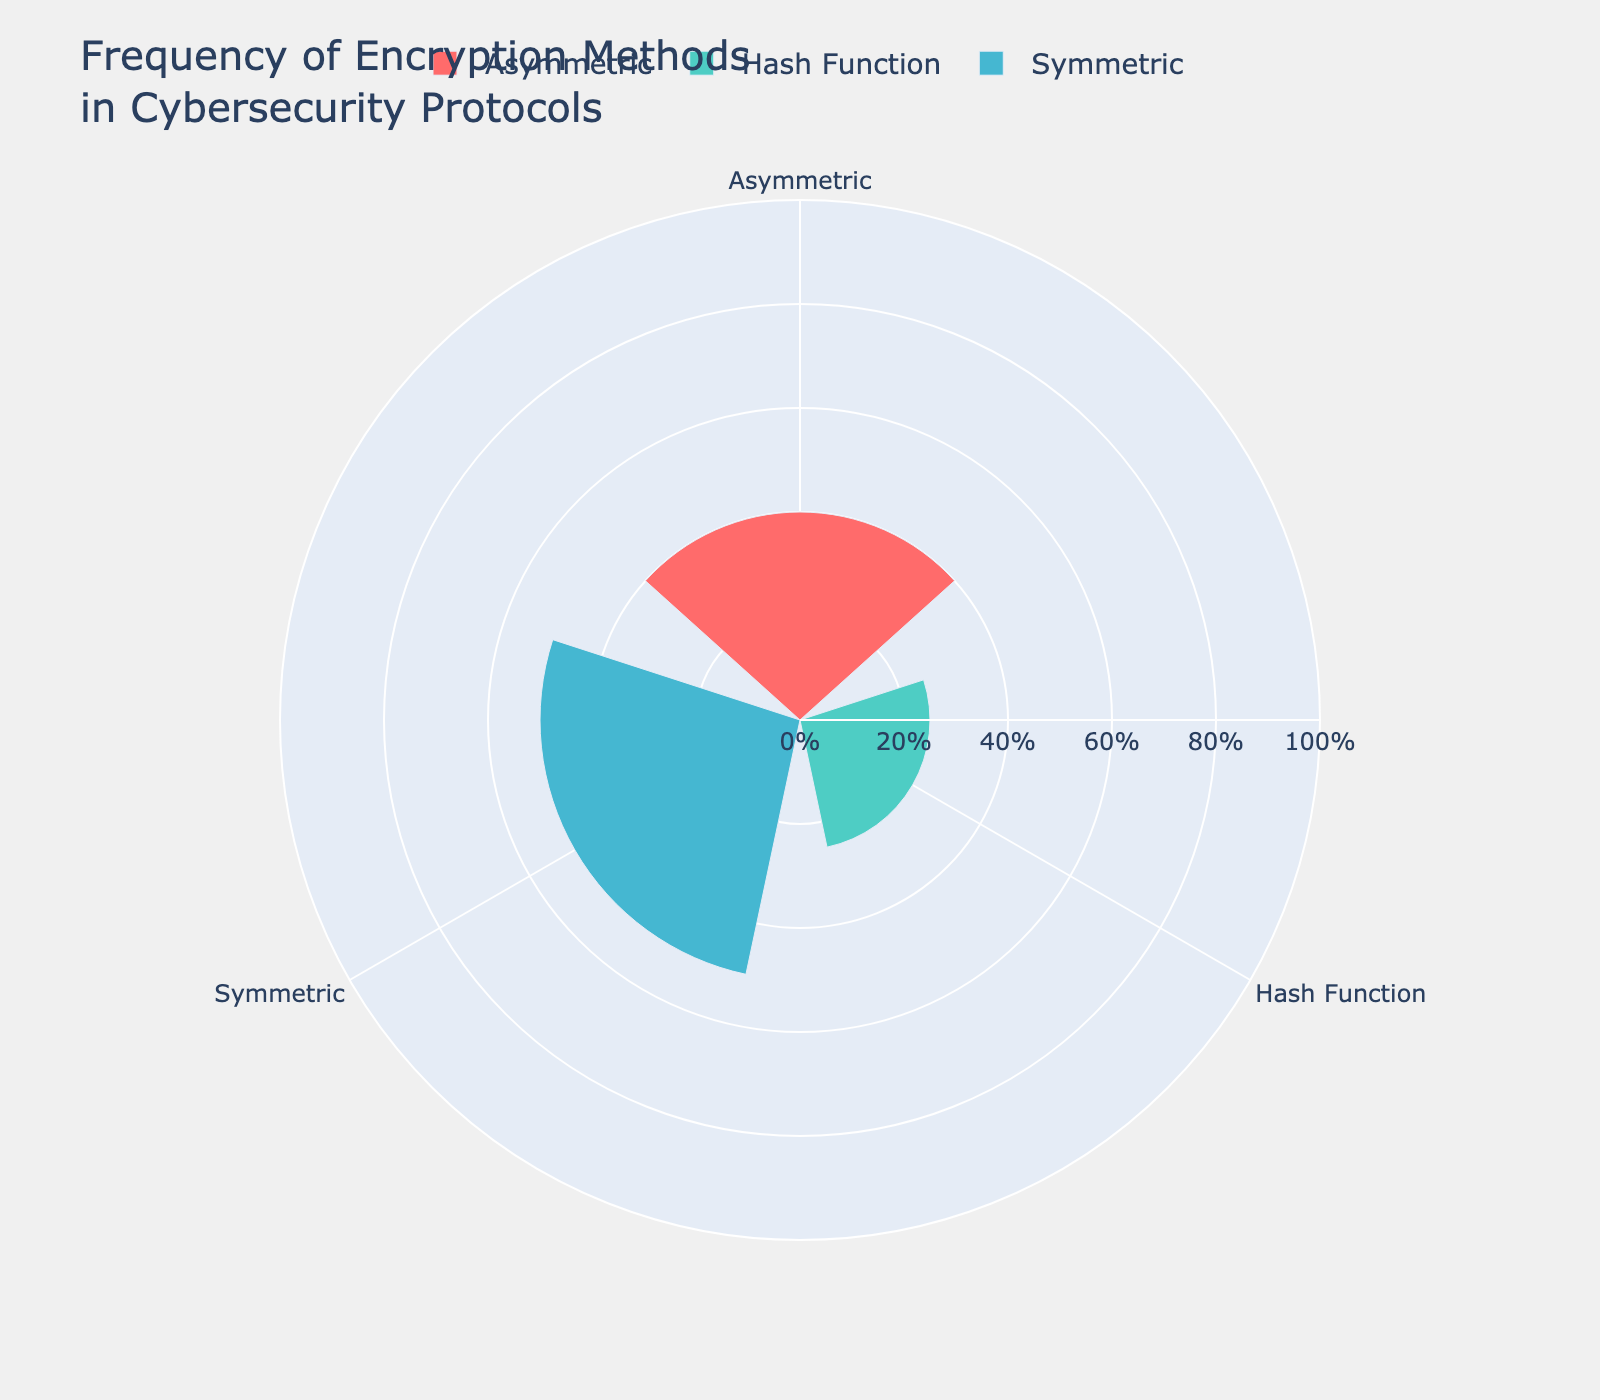What's the predominant encryption method used in the cybersecurity protocols? Look at the rose chart and identify the encryption method with the highest frequency.
Answer: Symmetric What's the combined frequency of the Hash Function methods? Sum the frequencies of SHA-256 and MD5. The values are 20 and 5 respectively, so 20 + 5 equals 25.
Answer: 25 Which encryption method is used the least frequently in cybersecurity protocols? Compare the frequencies of Symmetric, Asymmetric, and Hash Functions. Hash Functions have the lowest combined frequency.
Answer: Hash Functions How much more frequently is AES used compared to RSA? Subtract the frequency of RSA (30) from AES (45).
Answer: 15 What percentage of the total frequency does the Asymmetric encryption method represent? First, calculate the total combined frequency (45+5+30+10+20+5=115). Then sum the frequencies of Asymmetric methods (RSA=30, DSA=10) and divide by the total frequency. (40/115) * 100 ≈ 34.78%
Answer: 34.78% What's the difference in frequency between the most and least used methods? Subtract the frequency of the least used method (DES, 5) from the most used method (AES, 45).
Answer: 40 What is the average frequency of each encryption method type? First, sum the frequencies for each type: Symmetric (45+5=50), Asymmetric (30+10=40), and Hash Functions (20+5=25). Then divide each sum by the number of protocols in each type (2 for each). Symmetric average is 50/2=25, Asymmetric average is 40/2=20, Hash Functions average is 25/2=12.5.
Answer: Symmetric: 25, Asymmetric: 20, Hash Functions: 12.5 Between Symmetric and Hash Function methods, which has a higher average frequency per protocol? Calculate the average frequency for each: Symmetric (50/2=25), Hash Functions (25/2=12.5). Symmetric has the higher average.
Answer: Symmetric What is the rank ordering of encryption methods from most to least frequently used? List the encryption methods based on their total frequencies: Symmetric (50), Asymmetric (40), Hash Functions (25).
Answer: Symmetric, Asymmetric, Hash Functions 